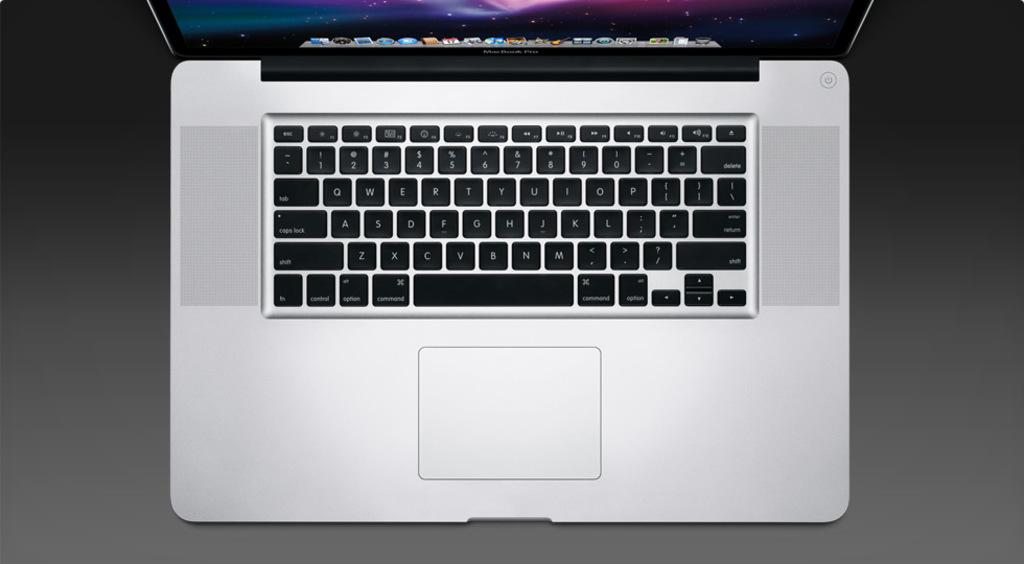What is the key to the right of the space bar?
Make the answer very short. Command. Name some of the keyboard keys?
Your answer should be compact. Answering does not require reading text in the image. 